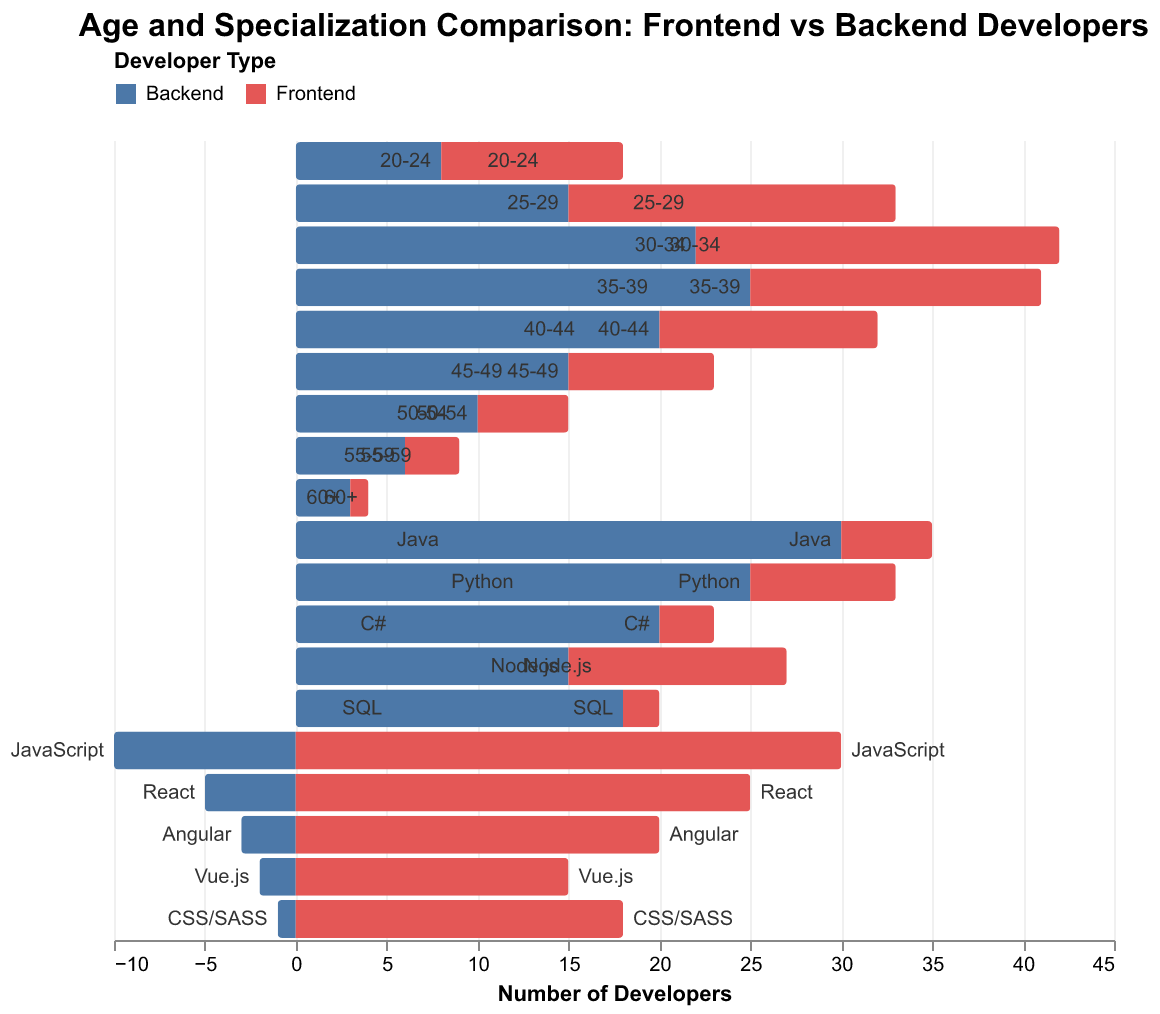What is the title of the figure? The title of the figure is located at the top and typically describes the main theme or focus of the visualization. In this case, it reads "Age and Specialization Comparison: Frontend vs Backend Developers"
Answer: Age and Specialization Comparison: Frontend vs Backend Developers How many back-end developers are aged 35-39? To determine the number of back-end developers aged 35-39, look at the bar corresponding to this age group and check the value associated with "Backend." Note that backend values are negative, representing the left side
Answer: 25 What's the number of front-end developers specialized in JavaScript? Locate the specialization "JavaScript," and check the associated bar value for "Frontend," which is represented on the right side of the pyramid
Answer: 30 Which age group has the highest number of front-end developers? By comparing the lengths of the bars for each age group on the right side of the pyramid, we can see that the age group 30-34 has the longest bar
Answer: 30-34 Which specialization has the highest number of backend developers? Focus on the left side of the pyramid, and find the bar that extends farthest to the left. It corresponds to "Java," which has the longest negative value for "Backend"
Answer: Java What's the total number of developers aged 60+? Add the number of front-end and back-end developers in the 60+ age group. Front-end: 1, Back-end: 3 (note the backend is negative, representing left side but number of developers is positive)
Answer: 4 Which specialization has equal numbers of front-end and back-end developers? Comparing the bars for frontend and backend for each specialization, none of them have exactly equal values
Answer: None Compare the number of front-end developers aged 25-29 to those specialized in React. Which group is larger and by how much? Check the front-end values for age 25-29 (18) and React specialization (25). Subtract the smaller from the larger to find the difference. In this case, 25 - 18 = 7
Answer: React, by 7 How many more front-end developers are specialized in CSS/SASS than are aged 55-59? Compare the front-end values in CSS/SASS (18) and 55-59 (3). Subtract 3 from 18 to find the difference
Answer: 15 What is the mean number of front-end developers across the specializations listed? Add the front-end values for all specializations: 5 + 8 + 3 + 12 + 2 + 30 + 25 + 20 + 15 + 18 = 138, then divide by the number of specializations (10)
Answer: 13.8 